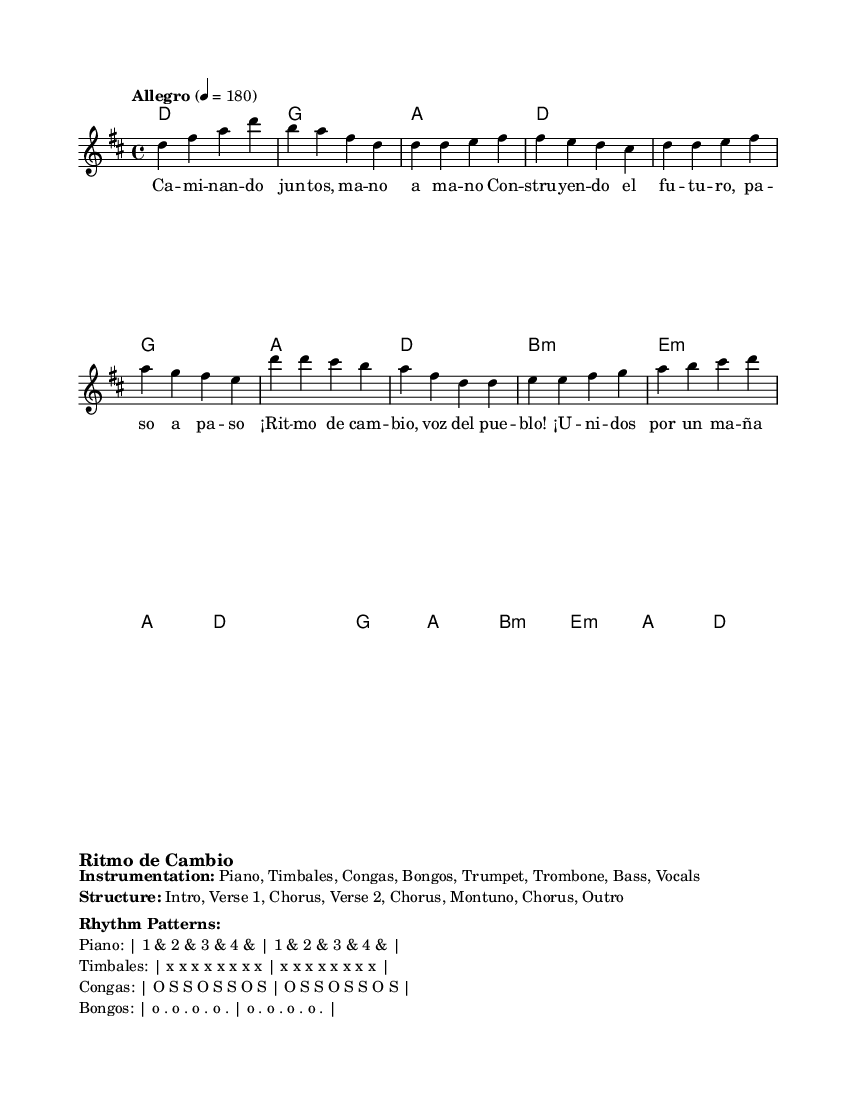What is the key signature of this music? The key signature is D major, which has two sharps (F sharp and C sharp). This is indicated at the beginning of the sheet music where the key signature is shown.
Answer: D major What is the time signature of this piece? The time signature shown at the beginning of the sheet music is 4/4, which means there are four beats in each measure and a quarter note gets one beat.
Answer: 4/4 What is the tempo marking for this composition? The tempo marking is "Allegro," which indicates a fast and lively tempo. The specific tempo is set to 180 beats per minute as indicated in the sheet music.
Answer: Allegro How many instruments are indicated in the instrumentation? The instrumentation list shows eight different instruments: Piano, Timbales, Congas, Bongos, Trumpet, Trombone, Bass, and Vocals. Counting these gives the total number.
Answer: Eight What are the two main lyrics sections of the song? The major sections of lyrics represented in the sheet music are the verse and chorus. The verse is stated first and is followed by the chorus.
Answer: Verse, Chorus How is the rhythm pattern of the Congas described? The Congas rhythm pattern is described in the markup section as "O S S O S S O S," which designates a specific rhythmic sequence for this instrument.
Answer: O S S O S S O S What kind of form does the overall structure of the piece follow? The structure of the piece is typical in Latin music, as indicated by the sections listed: Intro, Verse 1, Chorus, Verse 2, Chorus, Montuno, Chorus, Outro, indicating a combination of verses and repeated choruses.
Answer: Intro, Verse, Chorus, Montuno, Outro 